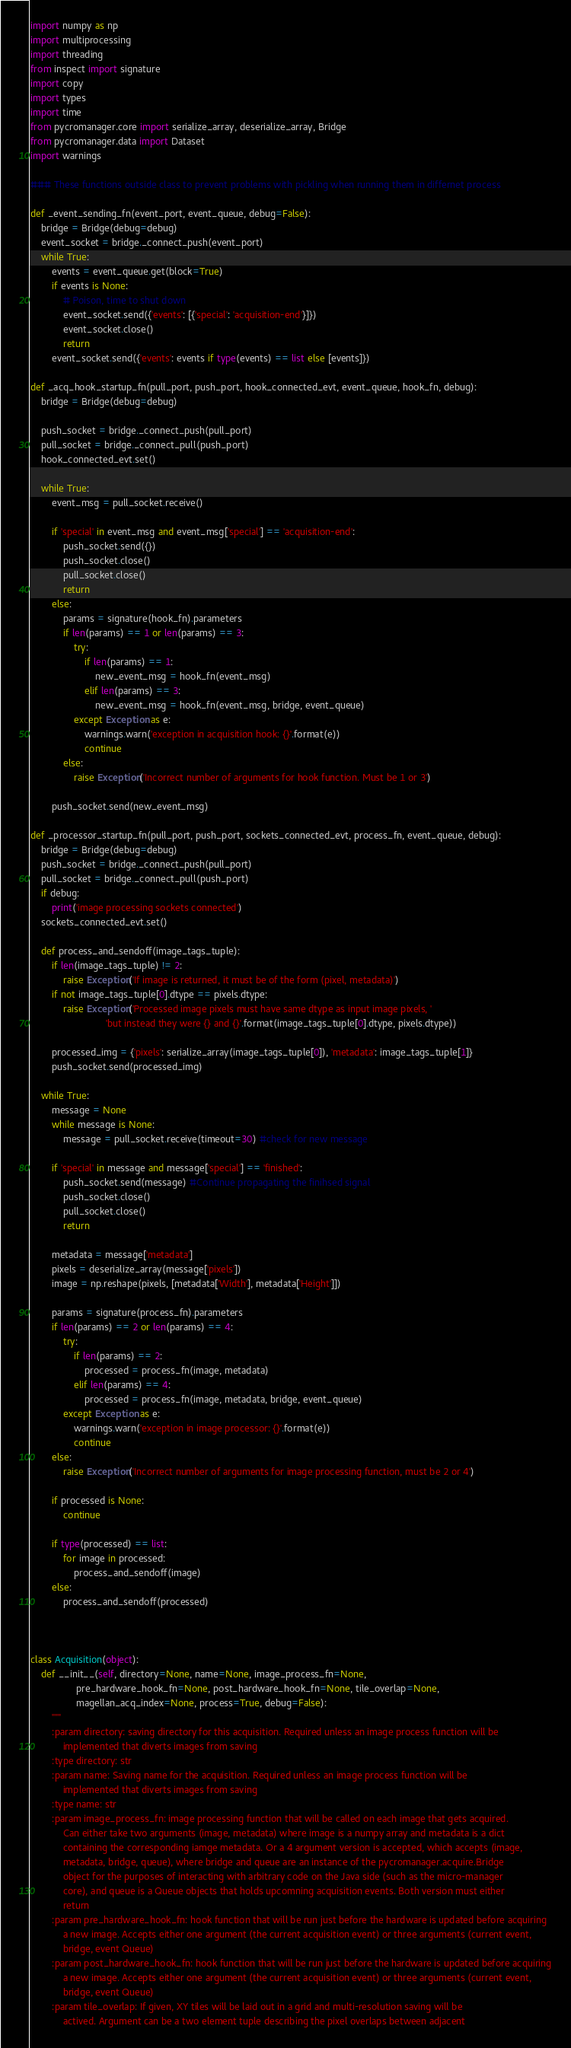<code> <loc_0><loc_0><loc_500><loc_500><_Python_>import numpy as np
import multiprocessing
import threading
from inspect import signature
import copy
import types
import time
from pycromanager.core import serialize_array, deserialize_array, Bridge
from pycromanager.data import Dataset
import warnings

### These functions outside class to prevent problems with pickling when running them in differnet process

def _event_sending_fn(event_port, event_queue, debug=False):
    bridge = Bridge(debug=debug)
    event_socket = bridge._connect_push(event_port)
    while True:
        events = event_queue.get(block=True)
        if events is None:
            # Poison, time to shut down
            event_socket.send({'events': [{'special': 'acquisition-end'}]})
            event_socket.close()
            return
        event_socket.send({'events': events if type(events) == list else [events]})

def _acq_hook_startup_fn(pull_port, push_port, hook_connected_evt, event_queue, hook_fn, debug):
    bridge = Bridge(debug=debug)

    push_socket = bridge._connect_push(pull_port)
    pull_socket = bridge._connect_pull(push_port)
    hook_connected_evt.set()

    while True:
        event_msg = pull_socket.receive()

        if 'special' in event_msg and event_msg['special'] == 'acquisition-end':
            push_socket.send({})
            push_socket.close()
            pull_socket.close()
            return
        else:
            params = signature(hook_fn).parameters
            if len(params) == 1 or len(params) == 3:
                try:
                    if len(params) == 1:
                        new_event_msg = hook_fn(event_msg)
                    elif len(params) == 3:
                        new_event_msg = hook_fn(event_msg, bridge, event_queue)
                except Exception as e:
                    warnings.warn('exception in acquisition hook: {}'.format(e))
                    continue
            else:
                raise Exception('Incorrect number of arguments for hook function. Must be 1 or 3')

        push_socket.send(new_event_msg)

def _processor_startup_fn(pull_port, push_port, sockets_connected_evt, process_fn, event_queue, debug):
    bridge = Bridge(debug=debug)
    push_socket = bridge._connect_push(pull_port)
    pull_socket = bridge._connect_pull(push_port)
    if debug:
        print('image processing sockets connected')
    sockets_connected_evt.set()

    def process_and_sendoff(image_tags_tuple):
        if len(image_tags_tuple) != 2:
            raise Exception('If image is returned, it must be of the form (pixel, metadata)')
        if not image_tags_tuple[0].dtype == pixels.dtype:
            raise Exception('Processed image pixels must have same dtype as input image pixels, '
                            'but instead they were {} and {}'.format(image_tags_tuple[0].dtype, pixels.dtype))

        processed_img = {'pixels': serialize_array(image_tags_tuple[0]), 'metadata': image_tags_tuple[1]}
        push_socket.send(processed_img)

    while True:
        message = None
        while message is None:
            message = pull_socket.receive(timeout=30) #check for new message

        if 'special' in message and message['special'] == 'finished':
            push_socket.send(message) #Continue propagating the finihsed signal
            push_socket.close()
            pull_socket.close()
            return

        metadata = message['metadata']
        pixels = deserialize_array(message['pixels'])
        image = np.reshape(pixels, [metadata['Width'], metadata['Height']])

        params = signature(process_fn).parameters
        if len(params) == 2 or len(params) == 4:
            try:
                if len(params) == 2:
                    processed = process_fn(image, metadata)
                elif len(params) == 4:
                    processed = process_fn(image, metadata, bridge, event_queue)
            except Exception as e:
                warnings.warn('exception in image processor: {}'.format(e))
                continue
        else:
            raise Exception('Incorrect number of arguments for image processing function, must be 2 or 4')

        if processed is None:
            continue

        if type(processed) == list:
            for image in processed:
                process_and_sendoff(image)
        else:
            process_and_sendoff(processed)



class Acquisition(object):
    def __init__(self, directory=None, name=None, image_process_fn=None,
                 pre_hardware_hook_fn=None, post_hardware_hook_fn=None, tile_overlap=None,
                 magellan_acq_index=None, process=True, debug=False):
        """
        :param directory: saving directory for this acquisition. Required unless an image process function will be
            implemented that diverts images from saving
        :type directory: str
        :param name: Saving name for the acquisition. Required unless an image process function will be
            implemented that diverts images from saving
        :type name: str
        :param image_process_fn: image processing function that will be called on each image that gets acquired.
            Can either take two arguments (image, metadata) where image is a numpy array and metadata is a dict
            containing the corresponding iamge metadata. Or a 4 argument version is accepted, which accepts (image,
            metadata, bridge, queue), where bridge and queue are an instance of the pycromanager.acquire.Bridge
            object for the purposes of interacting with arbitrary code on the Java side (such as the micro-manager
            core), and queue is a Queue objects that holds upcomning acquisition events. Both version must either
            return
        :param pre_hardware_hook_fn: hook function that will be run just before the hardware is updated before acquiring
            a new image. Accepts either one argument (the current acquisition event) or three arguments (current event,
            bridge, event Queue)
        :param post_hardware_hook_fn: hook function that will be run just before the hardware is updated before acquiring
            a new image. Accepts either one argument (the current acquisition event) or three arguments (current event,
            bridge, event Queue)
        :param tile_overlap: If given, XY tiles will be laid out in a grid and multi-resolution saving will be
            actived. Argument can be a two element tuple describing the pixel overlaps between adjacent</code> 